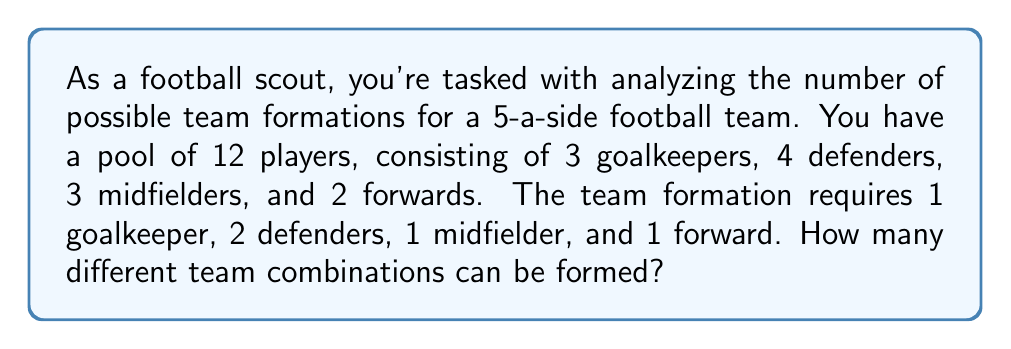Help me with this question. To solve this problem, we'll use the multiplication principle of counting. We need to choose players for each position independently and then multiply the number of choices for each position.

1. Goalkeeper: We need to choose 1 out of 3 goalkeepers.
   Number of ways = $\binom{3}{1} = 3$

2. Defenders: We need to choose 2 out of 4 defenders.
   Number of ways = $\binom{4}{2} = 6$

3. Midfielder: We need to choose 1 out of 3 midfielders.
   Number of ways = $\binom{3}{1} = 3$

4. Forward: We need to choose 1 out of 2 forwards.
   Number of ways = $\binom{2}{1} = 2$

Now, we apply the multiplication principle. The total number of team combinations is the product of the number of ways to choose players for each position:

$$\text{Total combinations} = 3 \times 6 \times 3 \times 2 = 108$$

Therefore, there are 108 different team combinations possible.
Answer: 108 different team combinations 